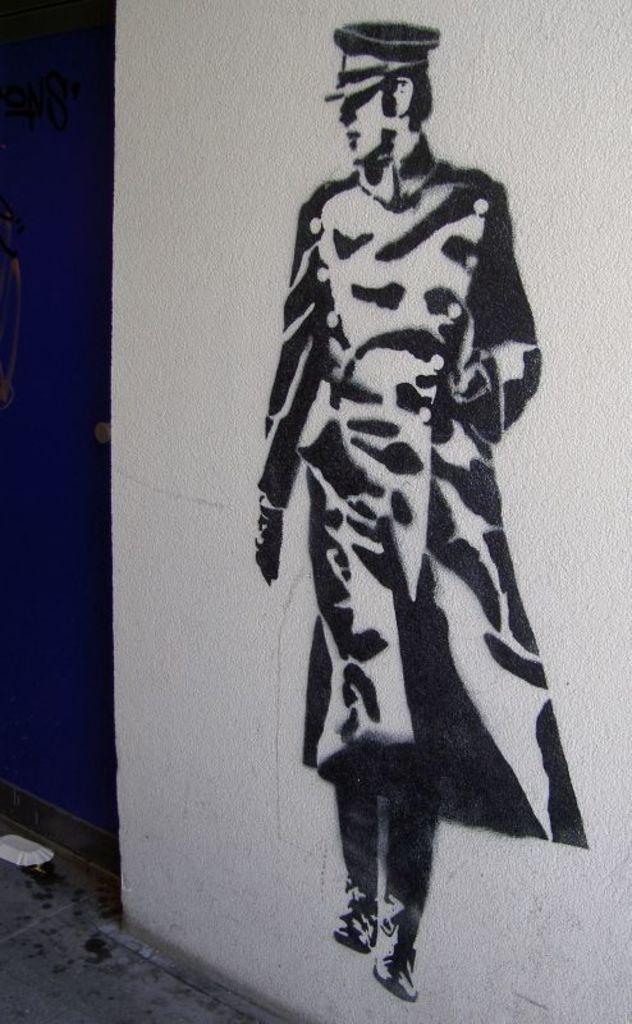Could you give a brief overview of what you see in this image? In this image, we can see human painting on the white wall. At the bottom, we can see a floor, paper cup. On the right side, we can see blue color. 